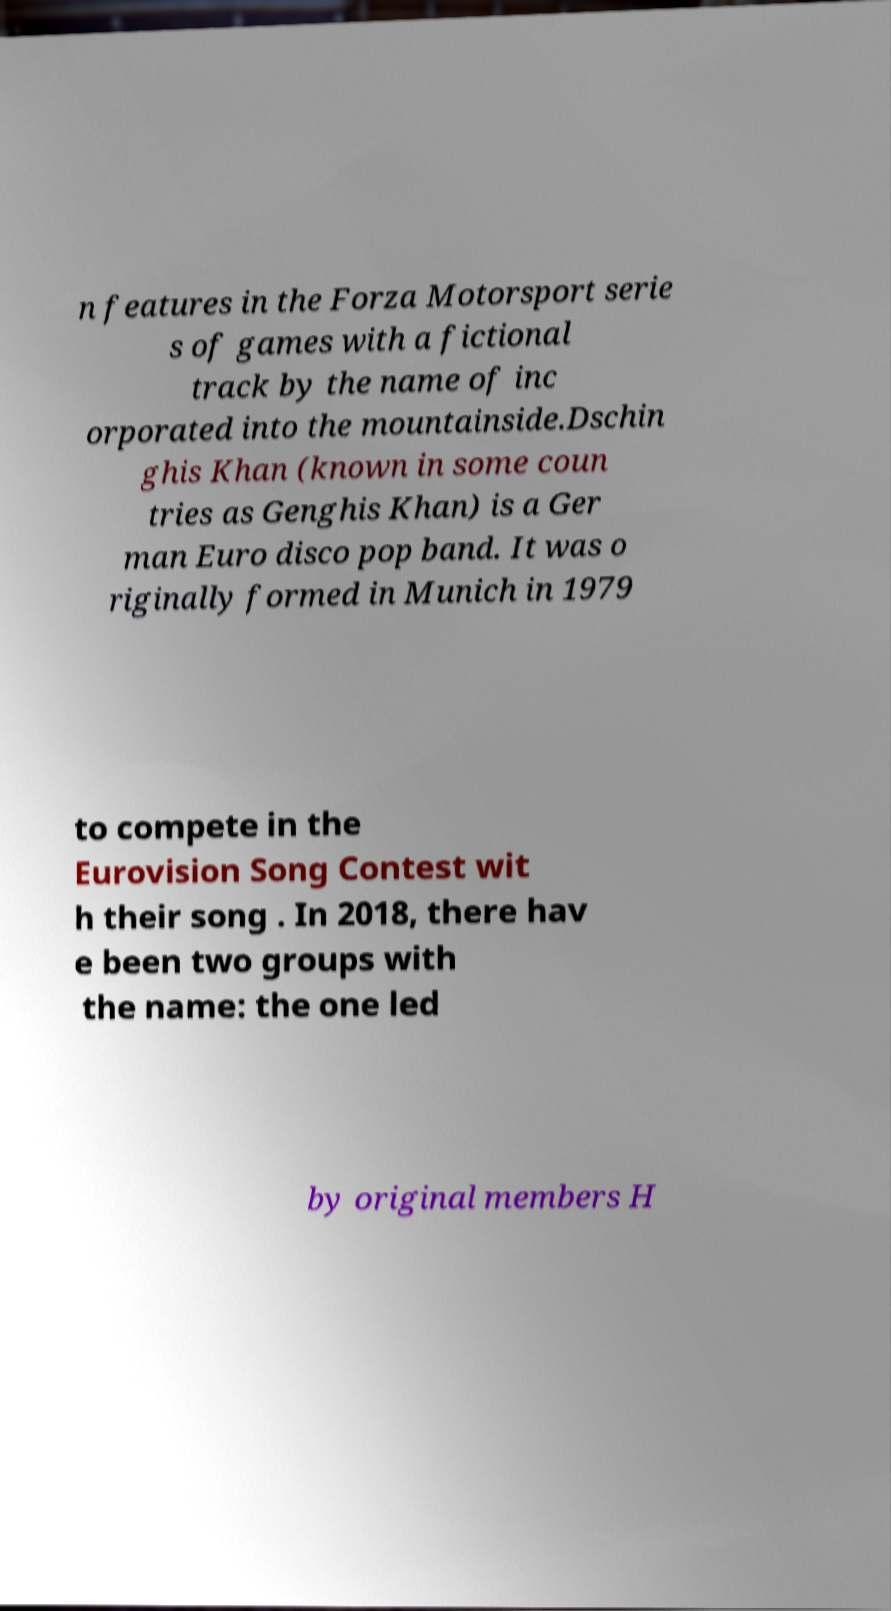Please read and relay the text visible in this image. What does it say? n features in the Forza Motorsport serie s of games with a fictional track by the name of inc orporated into the mountainside.Dschin ghis Khan (known in some coun tries as Genghis Khan) is a Ger man Euro disco pop band. It was o riginally formed in Munich in 1979 to compete in the Eurovision Song Contest wit h their song . In 2018, there hav e been two groups with the name: the one led by original members H 